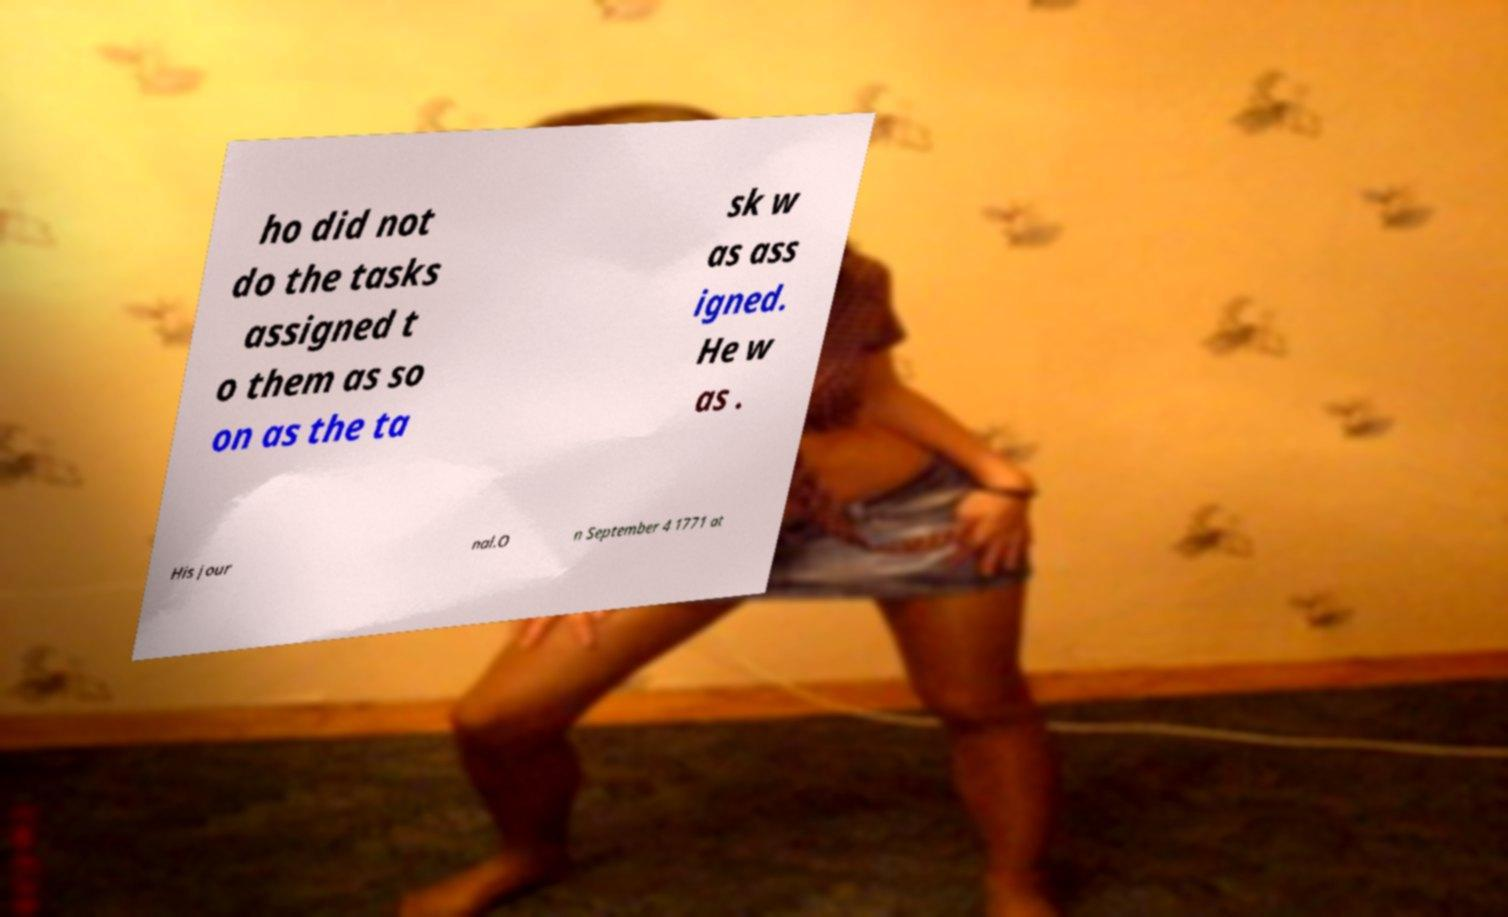Could you extract and type out the text from this image? ho did not do the tasks assigned t o them as so on as the ta sk w as ass igned. He w as . His jour nal.O n September 4 1771 at 